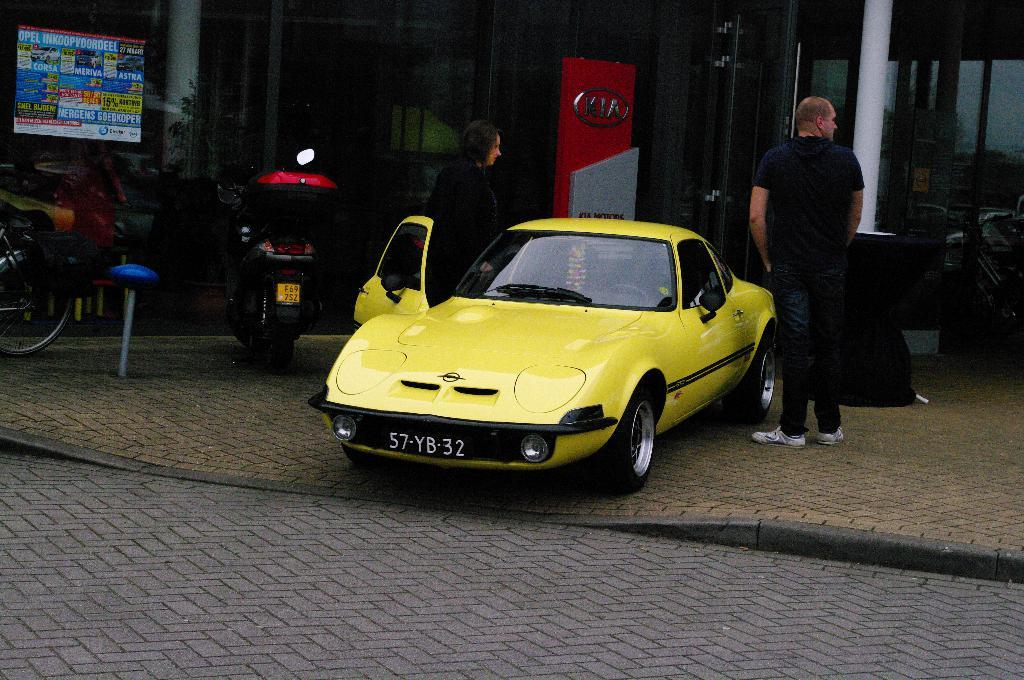Provide a one-sentence caption for the provided image. a yellow car that has the number 57 on it. 